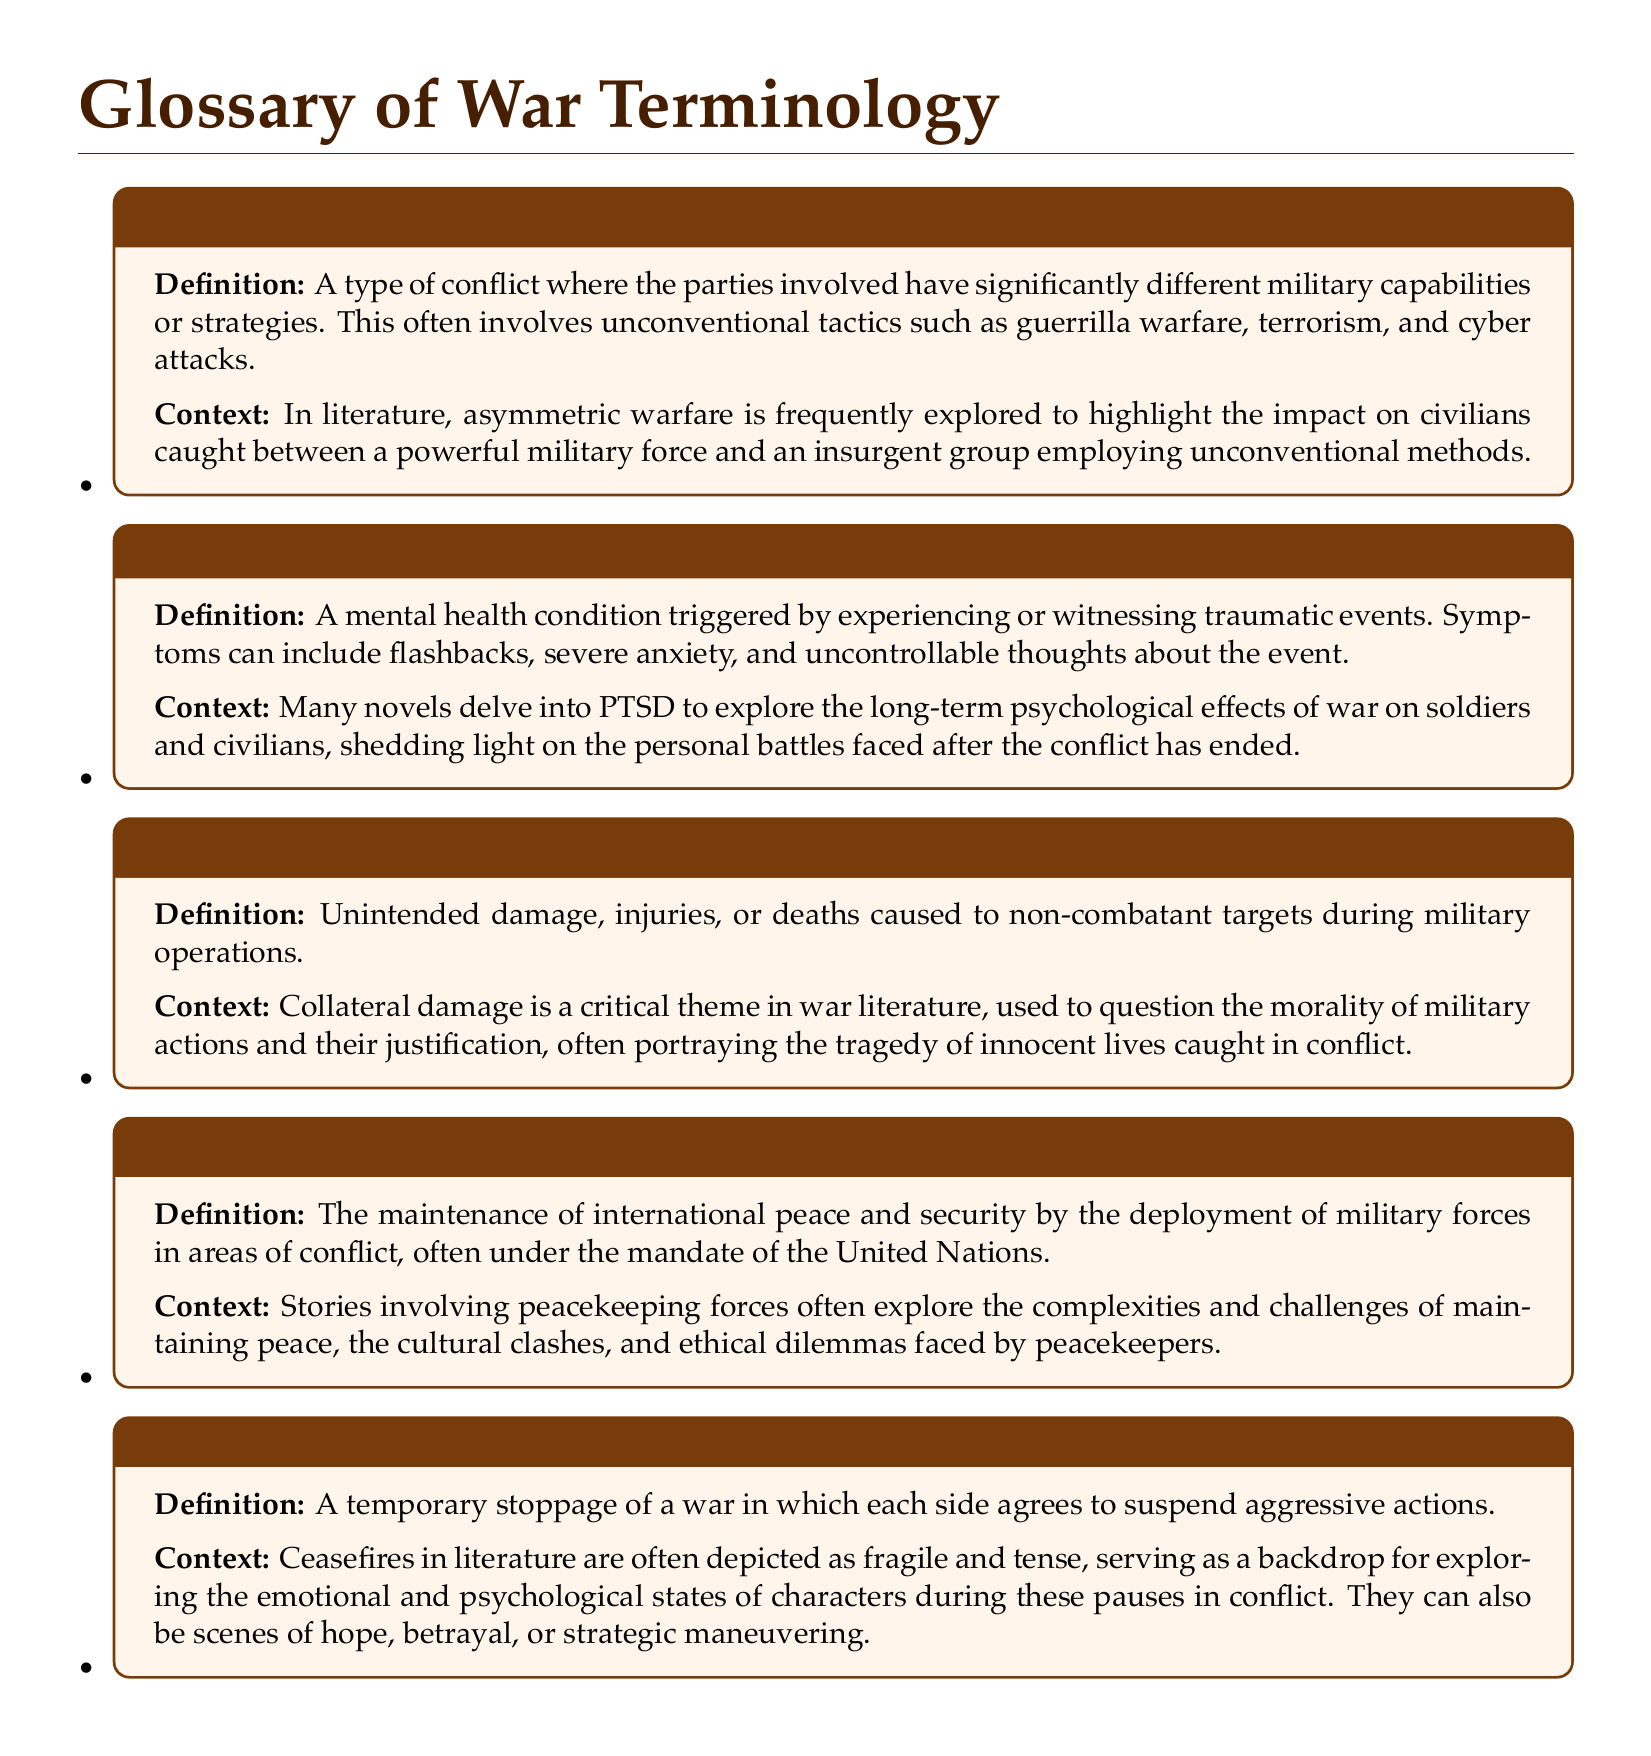What is the term for conflict with significantly different military capabilities? The document defines a type of conflict involving different military capabilities as asymmetric warfare.
Answer: Asymmetric Warfare What does PTSD stand for? The abbreviation PTSD is defined in the document as Post-Traumatic Stress Disorder.
Answer: Post-Traumatic Stress Disorder What is the context provided for collateral damage? The document states that collateral damage questions the morality of military actions and portrays tragedies.
Answer: Morality of military actions What is a temporary stoppage of war called? The document defines a temporary stoppage of a war where each side agrees to suspend actions as ceasefire.
Answer: Ceasefire What are the symptoms of PTSD mentioned? The symptoms listed in the document include flashbacks, severe anxiety, and uncontrollable thoughts about the event.
Answer: Flashbacks, severe anxiety, uncontrollable thoughts How is peacekeeping described in the document? The context for peacekeeping describes it as the maintenance of international peace and security through military deployment.
Answer: Maintenance of international peace and security What literary theme does collateral damage represent? The document suggests that collateral damage represents the consequence of innocent lives caught in conflict.
Answer: Tragedy of innocent lives How does literature portray ceasefires? The document mentions that ceasefires are depicted as fragile and tense, often exploring emotional states during these pauses.
Answer: Fragile and tense What unconventional tactics are associated with asymmetric warfare? The document includes guerrilla warfare, terrorism, and cyber attacks as tactics related to asymmetric warfare.
Answer: Guerrilla warfare, terrorism, cyber attacks 